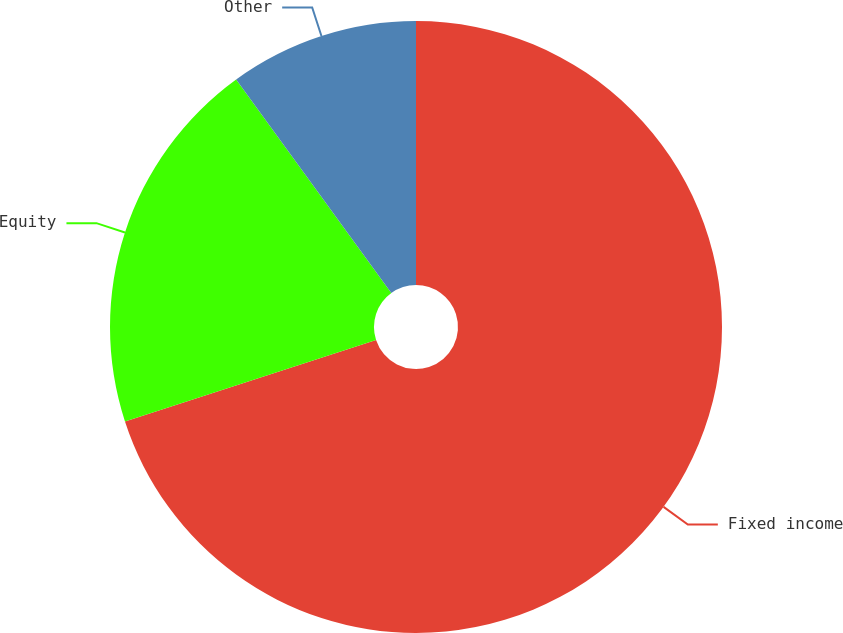<chart> <loc_0><loc_0><loc_500><loc_500><pie_chart><fcel>Fixed income<fcel>Equity<fcel>Other<nl><fcel>70.0%<fcel>20.0%<fcel>10.0%<nl></chart> 